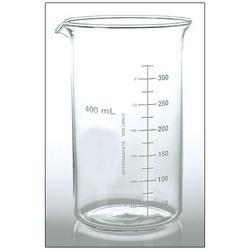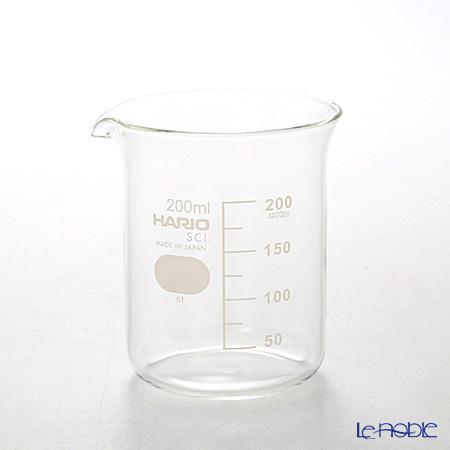The first image is the image on the left, the second image is the image on the right. Assess this claim about the two images: "There are two beakers facing left with one hexagon and one square printed on the beaker.". Correct or not? Answer yes or no. No. The first image is the image on the left, the second image is the image on the right. Given the left and right images, does the statement "One beaker has a gray hexagon shape next to its volume line, and the other beaker has a square shape." hold true? Answer yes or no. No. 